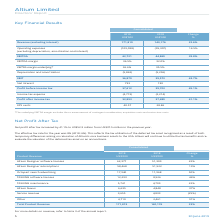From Altium Limited's financial document, What are the years included in the table? The document shows two values: 2019 and 2018. From the document: "30 June 2019 5 2018..." Also, What is the effective tax rate for 2019? According to the financial document, 8%. The relevant text states: "EBITDA 62,721 44,869 39.8%..." Also, What is the percentage change in the total product revenue from 2018 to 2019? According to the financial document, 23%. The relevant text states: "Total Product Revenue 171,819 140,176 23%..." Additionally, Which year had a higher Total Product Revenue?  According to the financial document, 2019. The relevant text states: "30 June 2019 5..." Also, can you calculate: What is the percentage of altium designer software licenses in total product revenue in 2018? Based on the calculation: 51,309/140,176, the result is 36.6 (percentage). This is based on the information: "Altium Designer software licenses 62,377 51,309 22% Total Product Revenue 171,819 140,176 23%..." The key data points involved are: 140,176, 51,309. Also, can you calculate: What is the percentage of TASKING software licenses in total product revenue in 2018? Based on the calculation: 8,526/140,176, the result is 6.08 (percentage). This is based on the information: "TASKING software licenses 12,293 8,526 44% Total Product Revenue 171,819 140,176 23%..." The key data points involved are: 140,176, 8,526. 